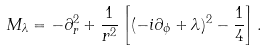<formula> <loc_0><loc_0><loc_500><loc_500>M _ { \lambda } = - \partial _ { r } ^ { 2 } + \frac { 1 } { r ^ { 2 } } \left [ ( - i \partial _ { \phi } + \lambda ) ^ { 2 } - \frac { 1 } { 4 } \right ] .</formula> 